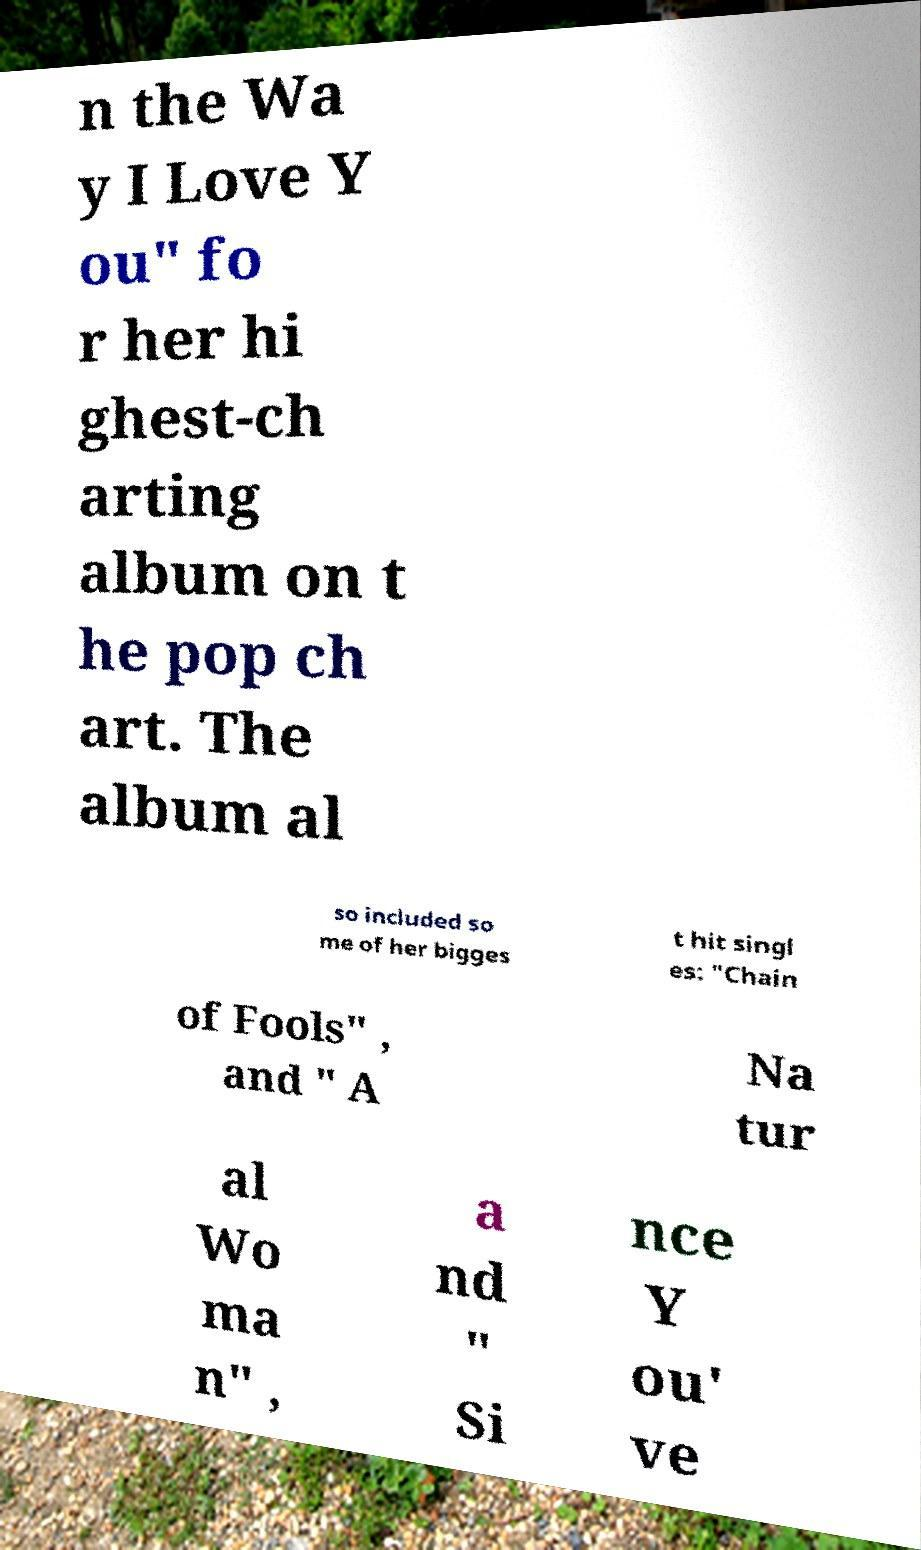For documentation purposes, I need the text within this image transcribed. Could you provide that? n the Wa y I Love Y ou" fo r her hi ghest-ch arting album on t he pop ch art. The album al so included so me of her bigges t hit singl es: "Chain of Fools" , and " A Na tur al Wo ma n" , a nd " Si nce Y ou' ve 